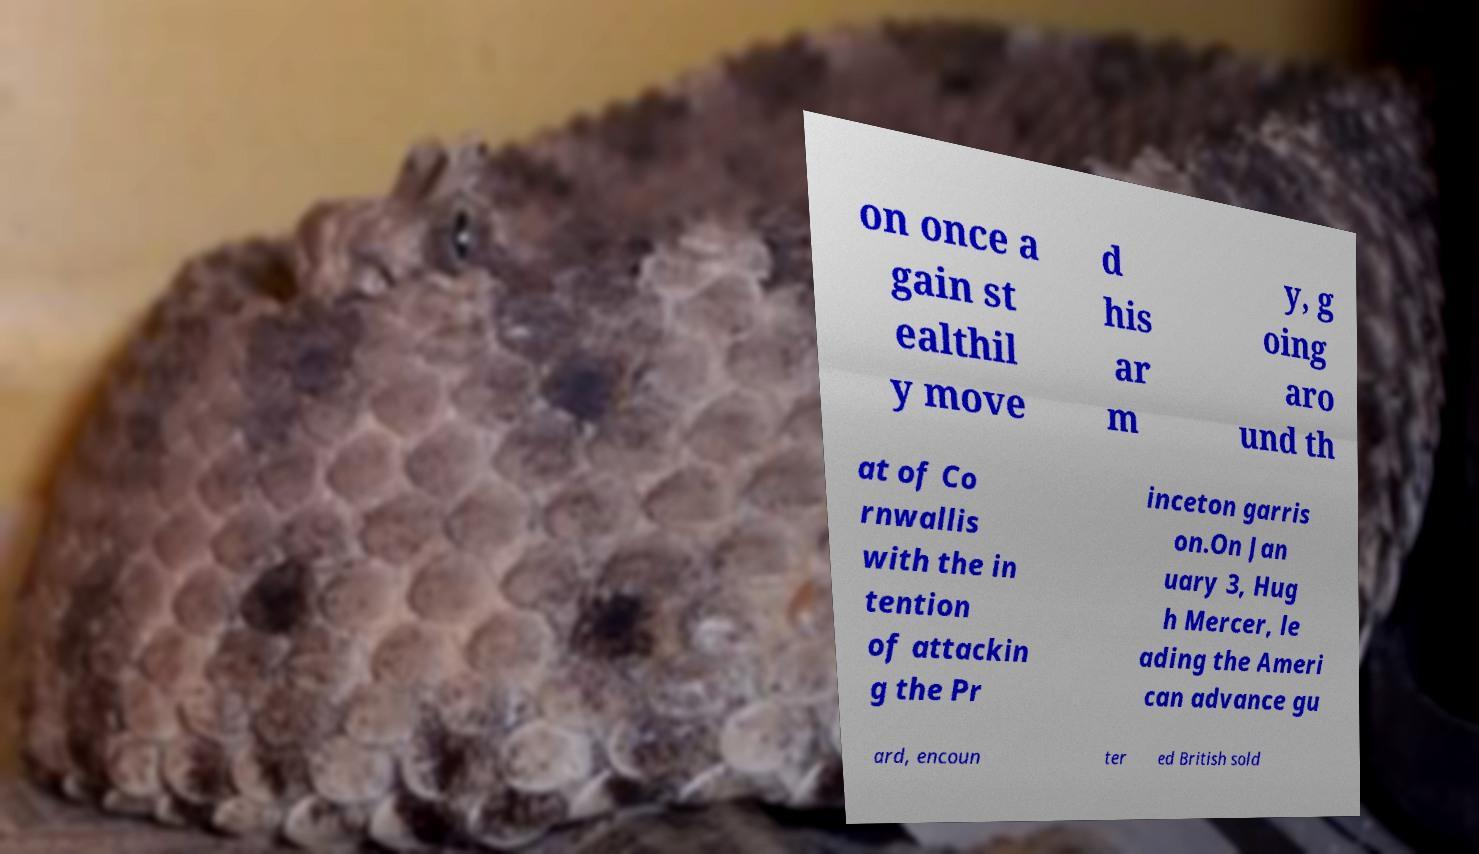Can you read and provide the text displayed in the image?This photo seems to have some interesting text. Can you extract and type it out for me? on once a gain st ealthil y move d his ar m y, g oing aro und th at of Co rnwallis with the in tention of attackin g the Pr inceton garris on.On Jan uary 3, Hug h Mercer, le ading the Ameri can advance gu ard, encoun ter ed British sold 